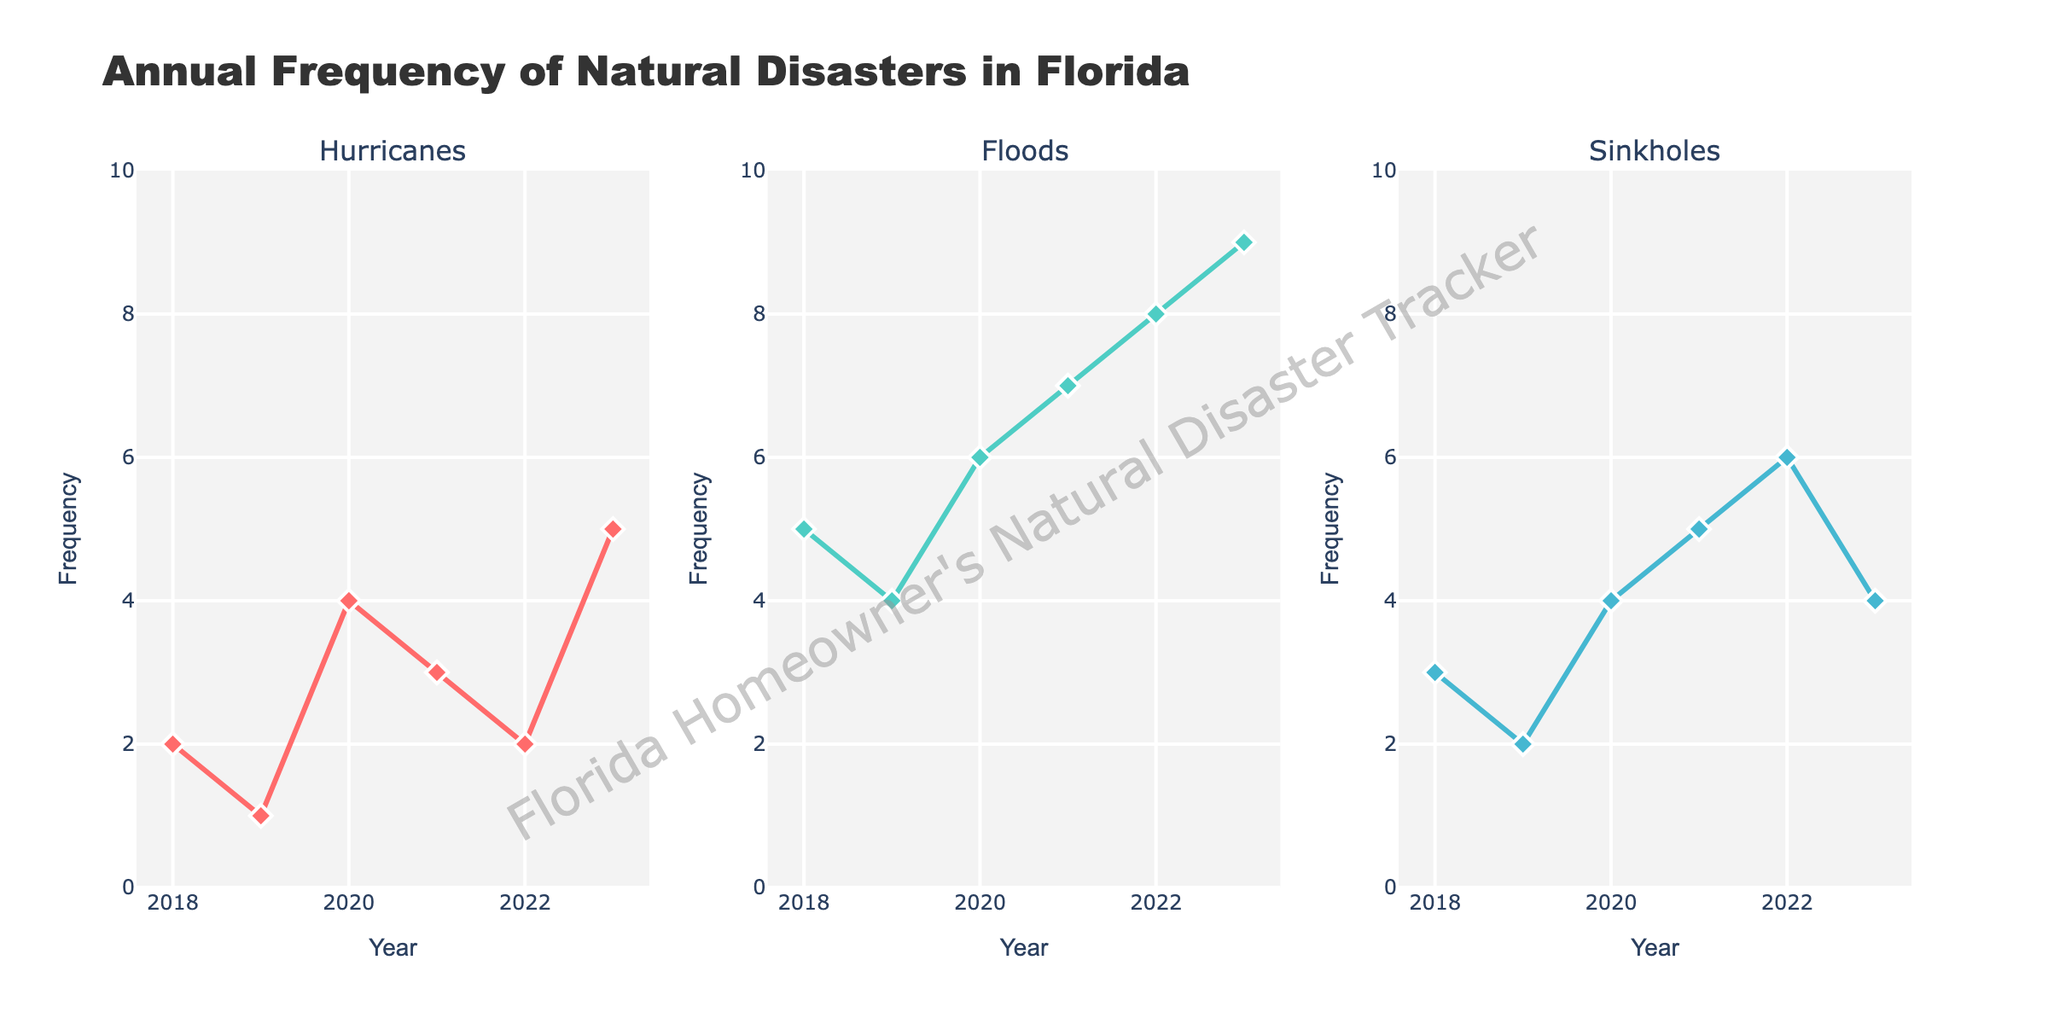What is the title of the chart? The title of the chart is clearly stated at the top of the figure as "Annual Frequency of Natural Disasters in Florida".
Answer: Annual Frequency of Natural Disasters in Florida Which type of natural disaster had the highest frequency in 2022? From the subplots for each natural disaster, by looking at the frequency corresponding to 2022, "Floods" had the highest frequency, as represented by the highest point, at 8.
Answer: Floods How many hurricanes were recorded in 2019? By examining the Hurricanes subplot for the point corresponding to 2019, the frequency is 1.
Answer: 1 In which year did sinkholes have their peak frequency, and what is that frequency? From the Sinkholes subplot, the highest point in the curve corresponds to 2022 with a frequency of 6.
Answer: 2022, 6 Which year had the highest overall number of natural disasters when summing hurricanes, floods, and sinkholes? Summing the frequencies for hurricanes, floods, and sinkholes for each year, 2023 has the highest overall number with 5 (hurricanes) + 9 (floods) + 4 (sinkholes) = 18.
Answer: 2023 How did the frequency of hurricanes change from 2020 to 2023? Observing the Hurricanes subplot, the frequency increased from 4 in 2020 to 5 in 2023, showing a net increase.
Answer: Increased What is the average frequency of floods from 2018 to 2023? Adding the frequencies from 2018 to 2023 for floods (5 + 4 + 6 + 7 + 8 + 9) gives 39. Dividing by the number of years (6), the average frequency is 39/6 = 6.5.
Answer: 6.5 How many years recorded more than 4 sinkholes? By checking the Sinkholes subplot for data points above 4, the years 2021, 2022, and 2023 recorded more than 4 sinkholes, totaling 3 years.
Answer: 3 Were there more floods or sinkholes recorded in 2020? Referring to the data points for 2020 in the Floods and Sinkholes subplots, floods had a frequency of 6 while sinkholes had 4. Hence, there were more floods.
Answer: Floods How does the trend of floods over the years compare with hurricanes? Observing the subplots for both Floods and Hurricanes, the trend for floods is consistently increasing from 5 to 9, whereas hurricanes fluctuate with no clear increasing or decreasing pattern overall.
Answer: Floods show an increasing trend while hurricanes fluctuate 